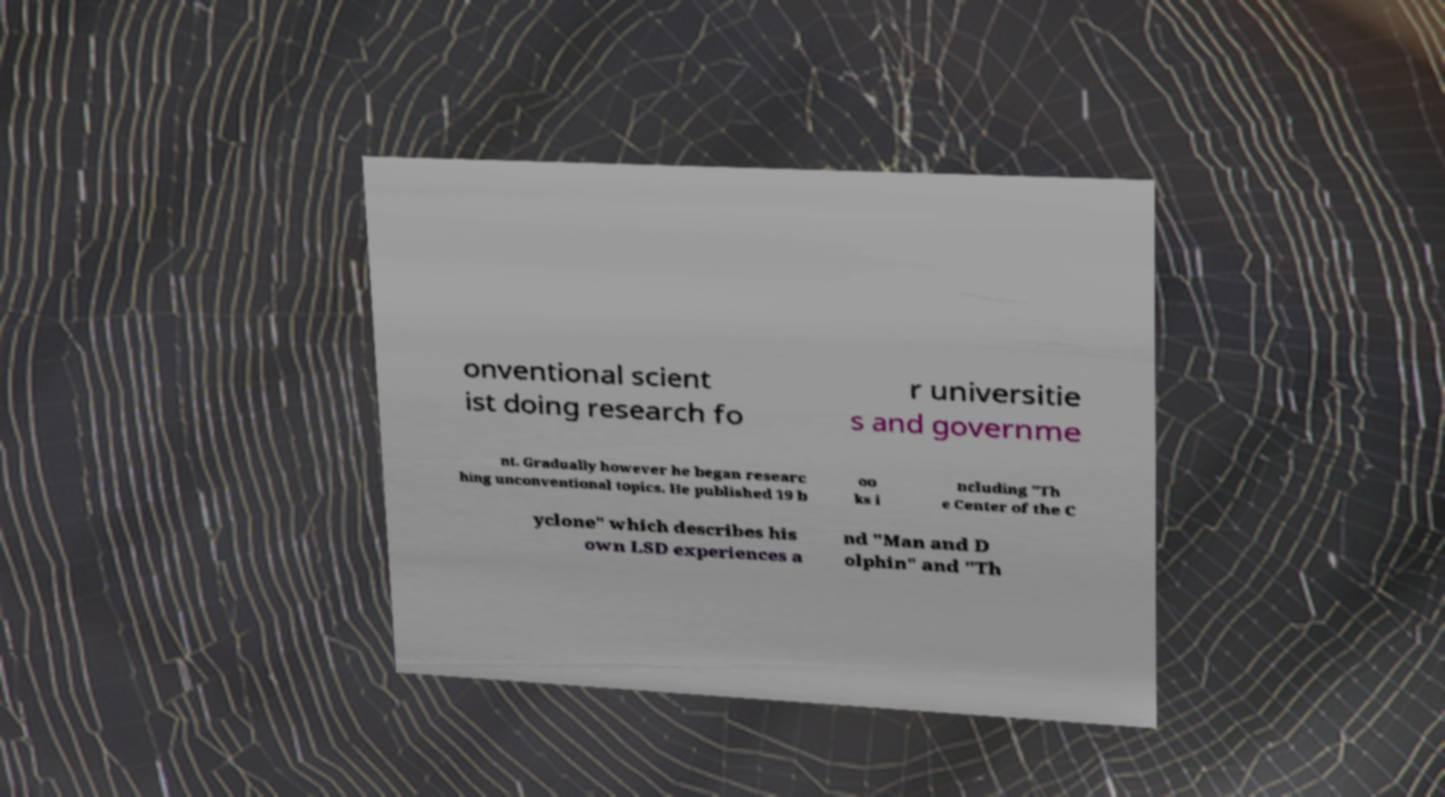Please read and relay the text visible in this image. What does it say? onventional scient ist doing research fo r universitie s and governme nt. Gradually however he began researc hing unconventional topics. He published 19 b oo ks i ncluding "Th e Center of the C yclone" which describes his own LSD experiences a nd "Man and D olphin" and "Th 